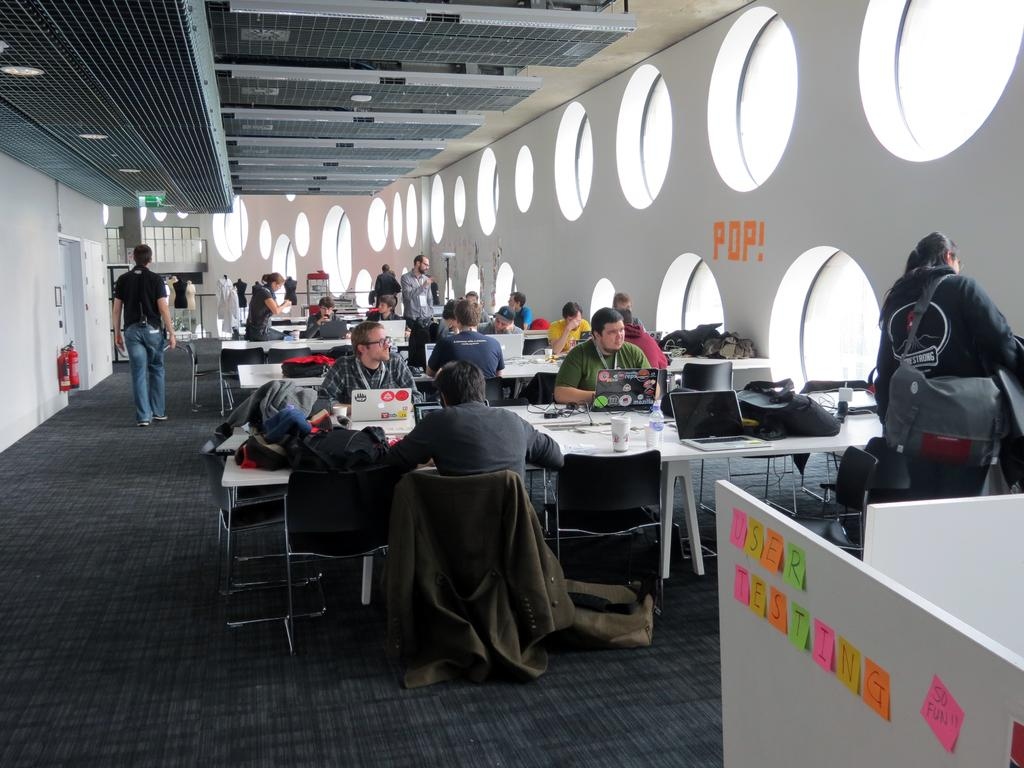<image>
Describe the image concisely. The inside of a room with Pop in sticky notes on the wall. 